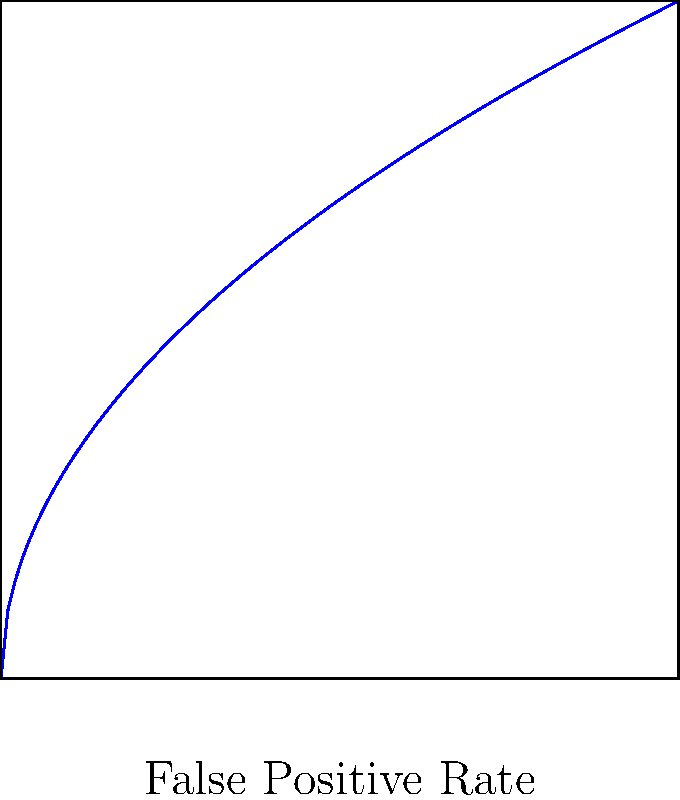Given the ROC curve for a machine learning model used in threat detection as shown in the graph, calculate the area under the curve (AUC) to evaluate the model's performance. The curve is defined by the function $f(x) = \sqrt{x}$ where $x$ represents the False Positive Rate and $f(x)$ represents the True Positive Rate. Use calculus to find the exact AUC value. To find the area under the ROC curve, we need to integrate the function $f(x) = \sqrt{x}$ from 0 to 1.

Step 1: Set up the integral
$$ AUC = \int_0^1 \sqrt{x} dx $$

Step 2: Use the power rule for integration
$$ \int x^n dx = \frac{x^{n+1}}{n+1} + C $$
For $\sqrt{x} = x^{1/2}$, we have:
$$ \int \sqrt{x} dx = \int x^{1/2} dx = \frac{x^{3/2}}{3/2} + C = \frac{2}{3}x^{3/2} + C $$

Step 3: Apply the limits of integration
$$ AUC = [\frac{2}{3}x^{3/2}]_0^1 = \frac{2}{3}(1^{3/2} - 0^{3/2}) = \frac{2}{3} $$

Therefore, the area under the ROC curve is $\frac{2}{3}$ or approximately 0.667.
Answer: $\frac{2}{3}$ 